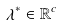<formula> <loc_0><loc_0><loc_500><loc_500>\lambda ^ { * } \in \mathbb { R } ^ { c }</formula> 